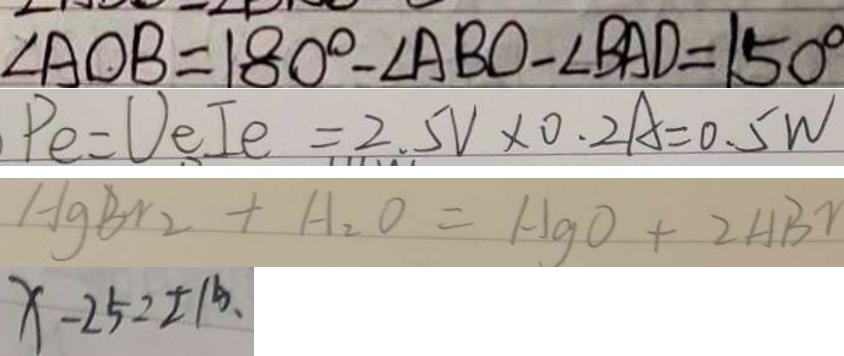<formula> <loc_0><loc_0><loc_500><loc_500>\angle A O B = 1 8 0 ^ { \circ } - \angle A B O - \angle B A D = 1 5 0 ^ { \circ } 
 P e = U e I e = 2 . 5 V \times 0 . 2 A = 0 . 5 W 
 H g B r _ { 2 } + H _ { 2 } O = H g O + 2 H B r 
 x - 2 5 = \pm 1 5 、</formula> 